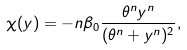<formula> <loc_0><loc_0><loc_500><loc_500>\chi ( y ) = - n \beta _ { 0 } \frac { \theta ^ { n } y ^ { n } } { ( \theta ^ { n } + y ^ { n } ) ^ { 2 } } ,</formula> 